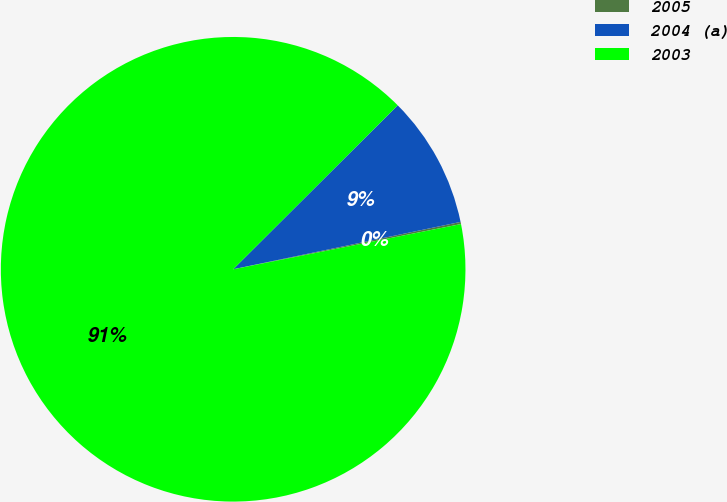<chart> <loc_0><loc_0><loc_500><loc_500><pie_chart><fcel>2005<fcel>2004 (a)<fcel>2003<nl><fcel>0.15%<fcel>9.2%<fcel>90.64%<nl></chart> 